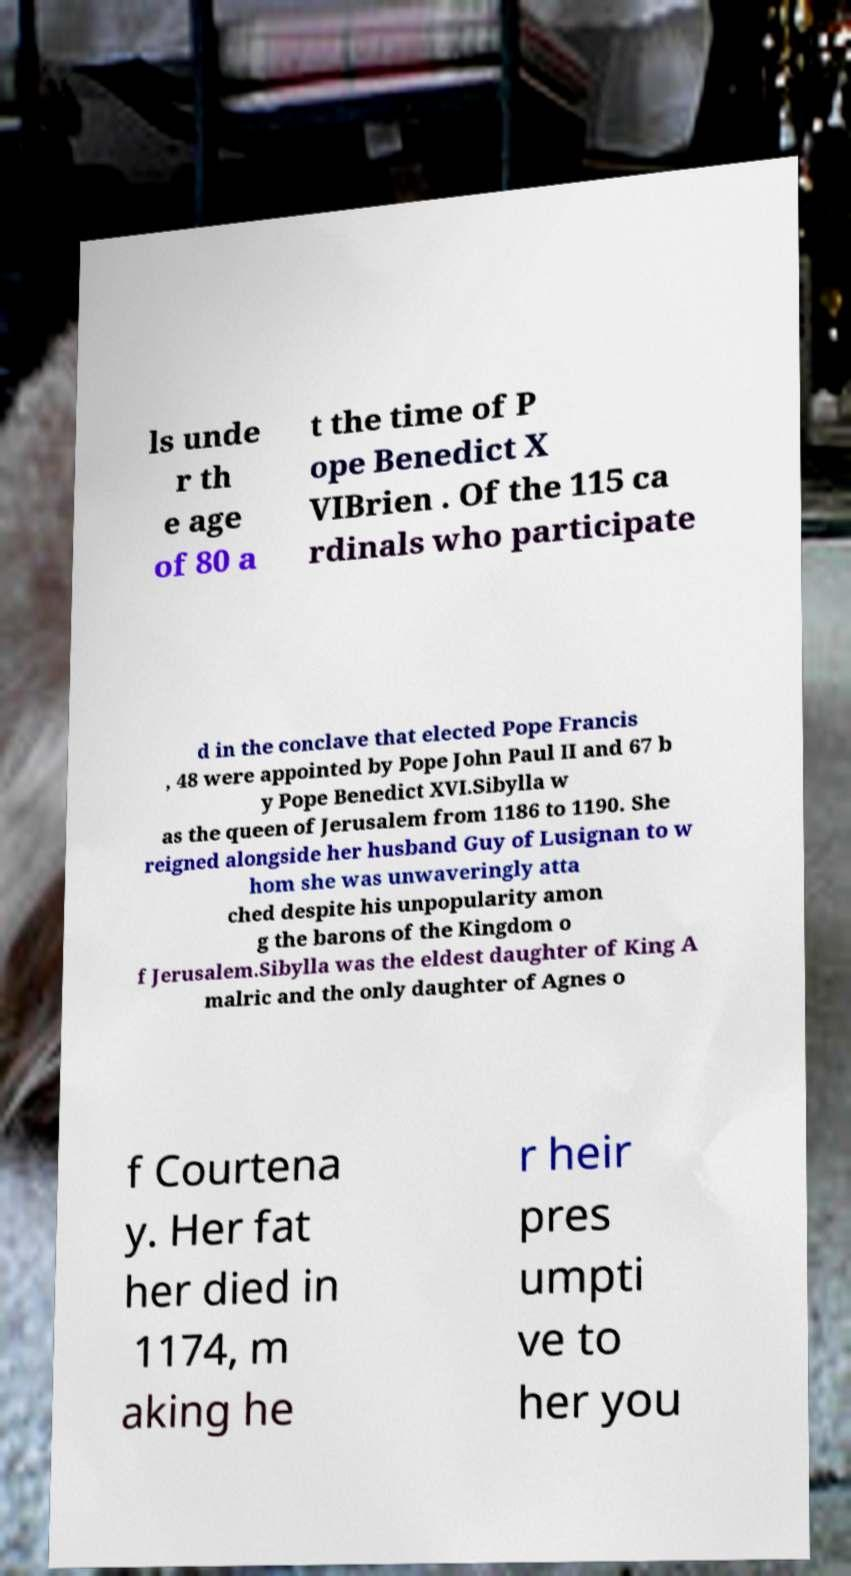I need the written content from this picture converted into text. Can you do that? ls unde r th e age of 80 a t the time of P ope Benedict X VIBrien . Of the 115 ca rdinals who participate d in the conclave that elected Pope Francis , 48 were appointed by Pope John Paul II and 67 b y Pope Benedict XVI.Sibylla w as the queen of Jerusalem from 1186 to 1190. She reigned alongside her husband Guy of Lusignan to w hom she was unwaveringly atta ched despite his unpopularity amon g the barons of the Kingdom o f Jerusalem.Sibylla was the eldest daughter of King A malric and the only daughter of Agnes o f Courtena y. Her fat her died in 1174, m aking he r heir pres umpti ve to her you 